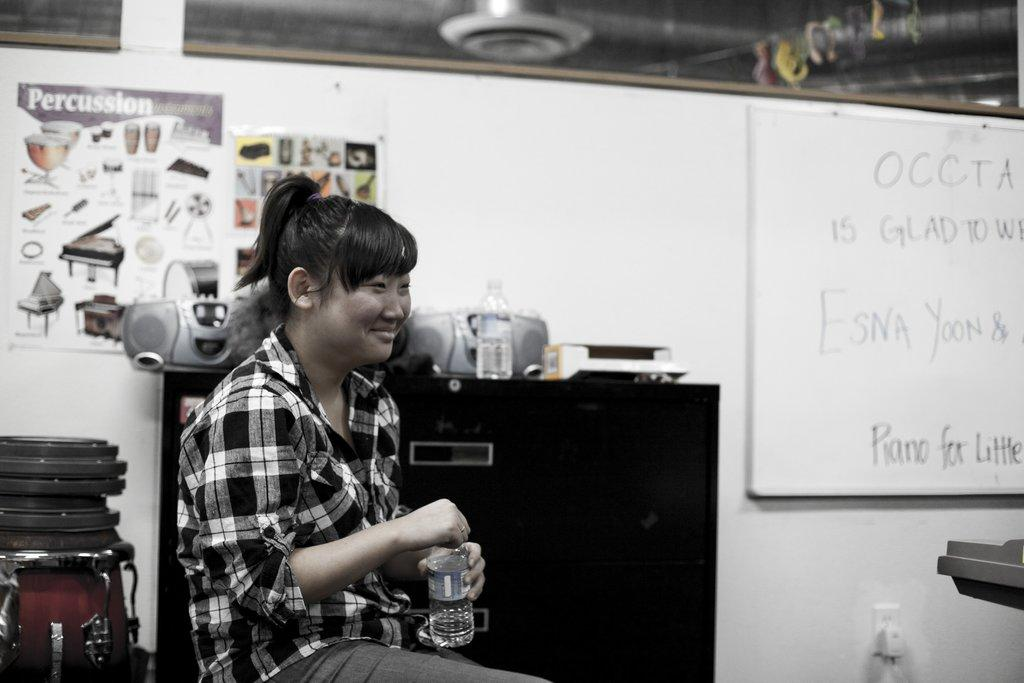<image>
Relay a brief, clear account of the picture shown. A woman sitting in front of a percussion poster. 